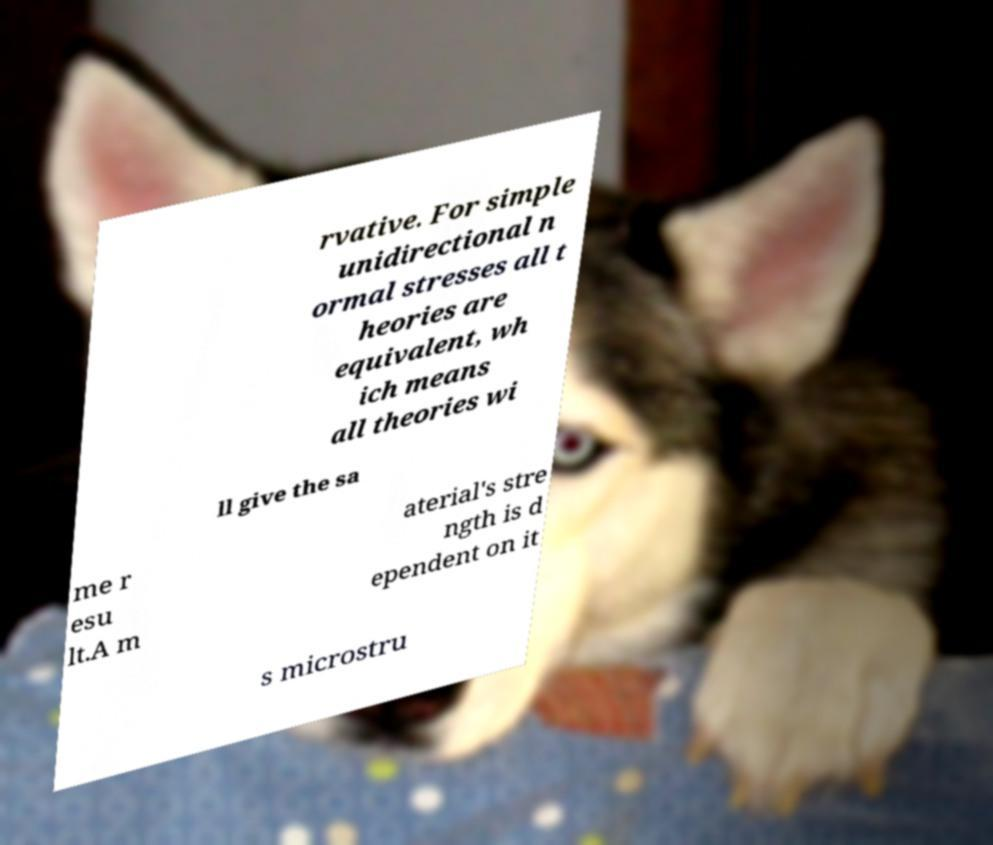Could you extract and type out the text from this image? rvative. For simple unidirectional n ormal stresses all t heories are equivalent, wh ich means all theories wi ll give the sa me r esu lt.A m aterial's stre ngth is d ependent on it s microstru 